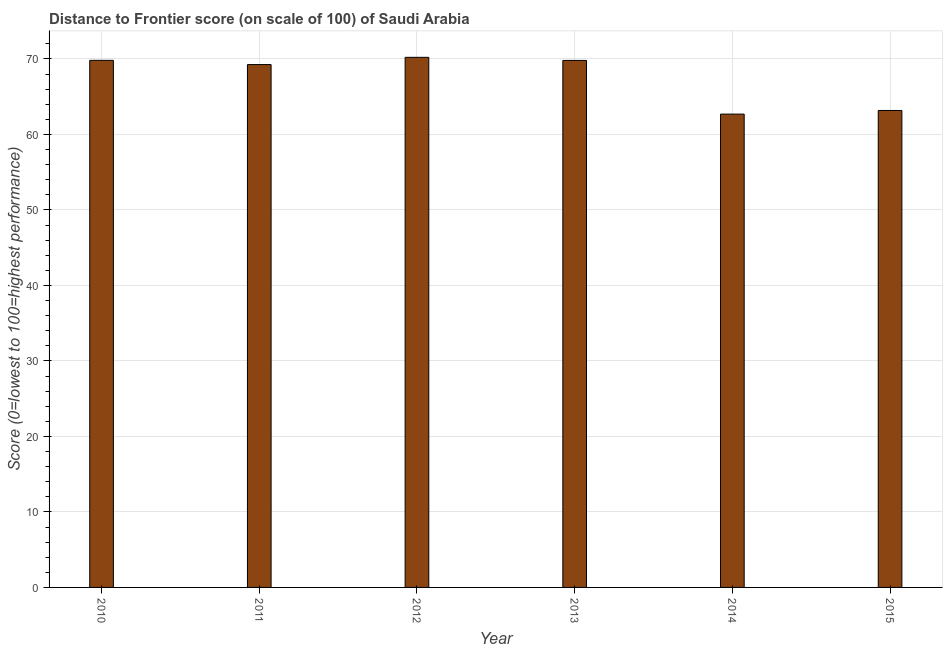What is the title of the graph?
Keep it short and to the point. Distance to Frontier score (on scale of 100) of Saudi Arabia. What is the label or title of the X-axis?
Your response must be concise. Year. What is the label or title of the Y-axis?
Provide a succinct answer. Score (0=lowest to 100=highest performance). What is the distance to frontier score in 2010?
Offer a very short reply. 69.81. Across all years, what is the maximum distance to frontier score?
Provide a short and direct response. 70.21. Across all years, what is the minimum distance to frontier score?
Make the answer very short. 62.69. What is the sum of the distance to frontier score?
Your response must be concise. 404.93. What is the difference between the distance to frontier score in 2013 and 2015?
Your answer should be compact. 6.63. What is the average distance to frontier score per year?
Ensure brevity in your answer.  67.49. What is the median distance to frontier score?
Provide a succinct answer. 69.53. In how many years, is the distance to frontier score greater than 50 ?
Give a very brief answer. 6. What is the ratio of the distance to frontier score in 2010 to that in 2012?
Offer a terse response. 0.99. What is the difference between the highest and the lowest distance to frontier score?
Keep it short and to the point. 7.52. In how many years, is the distance to frontier score greater than the average distance to frontier score taken over all years?
Your response must be concise. 4. How many bars are there?
Give a very brief answer. 6. How many years are there in the graph?
Offer a terse response. 6. What is the difference between two consecutive major ticks on the Y-axis?
Give a very brief answer. 10. What is the Score (0=lowest to 100=highest performance) in 2010?
Offer a very short reply. 69.81. What is the Score (0=lowest to 100=highest performance) of 2011?
Keep it short and to the point. 69.25. What is the Score (0=lowest to 100=highest performance) of 2012?
Ensure brevity in your answer.  70.21. What is the Score (0=lowest to 100=highest performance) in 2013?
Offer a terse response. 69.8. What is the Score (0=lowest to 100=highest performance) in 2014?
Ensure brevity in your answer.  62.69. What is the Score (0=lowest to 100=highest performance) of 2015?
Provide a short and direct response. 63.17. What is the difference between the Score (0=lowest to 100=highest performance) in 2010 and 2011?
Ensure brevity in your answer.  0.56. What is the difference between the Score (0=lowest to 100=highest performance) in 2010 and 2013?
Your answer should be compact. 0.01. What is the difference between the Score (0=lowest to 100=highest performance) in 2010 and 2014?
Offer a very short reply. 7.12. What is the difference between the Score (0=lowest to 100=highest performance) in 2010 and 2015?
Give a very brief answer. 6.64. What is the difference between the Score (0=lowest to 100=highest performance) in 2011 and 2012?
Make the answer very short. -0.96. What is the difference between the Score (0=lowest to 100=highest performance) in 2011 and 2013?
Ensure brevity in your answer.  -0.55. What is the difference between the Score (0=lowest to 100=highest performance) in 2011 and 2014?
Ensure brevity in your answer.  6.56. What is the difference between the Score (0=lowest to 100=highest performance) in 2011 and 2015?
Provide a short and direct response. 6.08. What is the difference between the Score (0=lowest to 100=highest performance) in 2012 and 2013?
Your answer should be compact. 0.41. What is the difference between the Score (0=lowest to 100=highest performance) in 2012 and 2014?
Make the answer very short. 7.52. What is the difference between the Score (0=lowest to 100=highest performance) in 2012 and 2015?
Provide a succinct answer. 7.04. What is the difference between the Score (0=lowest to 100=highest performance) in 2013 and 2014?
Keep it short and to the point. 7.11. What is the difference between the Score (0=lowest to 100=highest performance) in 2013 and 2015?
Provide a short and direct response. 6.63. What is the difference between the Score (0=lowest to 100=highest performance) in 2014 and 2015?
Provide a succinct answer. -0.48. What is the ratio of the Score (0=lowest to 100=highest performance) in 2010 to that in 2011?
Your answer should be compact. 1.01. What is the ratio of the Score (0=lowest to 100=highest performance) in 2010 to that in 2014?
Offer a very short reply. 1.11. What is the ratio of the Score (0=lowest to 100=highest performance) in 2010 to that in 2015?
Make the answer very short. 1.1. What is the ratio of the Score (0=lowest to 100=highest performance) in 2011 to that in 2012?
Provide a short and direct response. 0.99. What is the ratio of the Score (0=lowest to 100=highest performance) in 2011 to that in 2014?
Give a very brief answer. 1.1. What is the ratio of the Score (0=lowest to 100=highest performance) in 2011 to that in 2015?
Provide a succinct answer. 1.1. What is the ratio of the Score (0=lowest to 100=highest performance) in 2012 to that in 2013?
Keep it short and to the point. 1.01. What is the ratio of the Score (0=lowest to 100=highest performance) in 2012 to that in 2014?
Give a very brief answer. 1.12. What is the ratio of the Score (0=lowest to 100=highest performance) in 2012 to that in 2015?
Keep it short and to the point. 1.11. What is the ratio of the Score (0=lowest to 100=highest performance) in 2013 to that in 2014?
Keep it short and to the point. 1.11. What is the ratio of the Score (0=lowest to 100=highest performance) in 2013 to that in 2015?
Offer a very short reply. 1.1. 